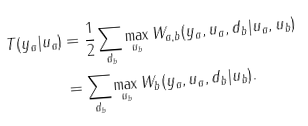<formula> <loc_0><loc_0><loc_500><loc_500>T ( y _ { a } | u _ { a } ) & = \frac { 1 } { 2 } \sum _ { d _ { b } } \max _ { u _ { b } } W _ { a , b } ( y _ { a } , u _ { a } , d _ { b } | u _ { a } , u _ { b } ) \\ & = \sum _ { d _ { b } } \max _ { u _ { b } } W _ { b } ( y _ { a } , u _ { a } , d _ { b } | u _ { b } ) .</formula> 